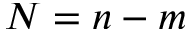Convert formula to latex. <formula><loc_0><loc_0><loc_500><loc_500>N = n - m</formula> 